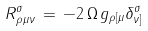<formula> <loc_0><loc_0><loc_500><loc_500>R ^ { \sigma } _ { \, \rho \mu \nu } \, = \, - 2 \, \Omega \, g _ { \rho [ \mu } \delta _ { \nu ] } ^ { \sigma }</formula> 